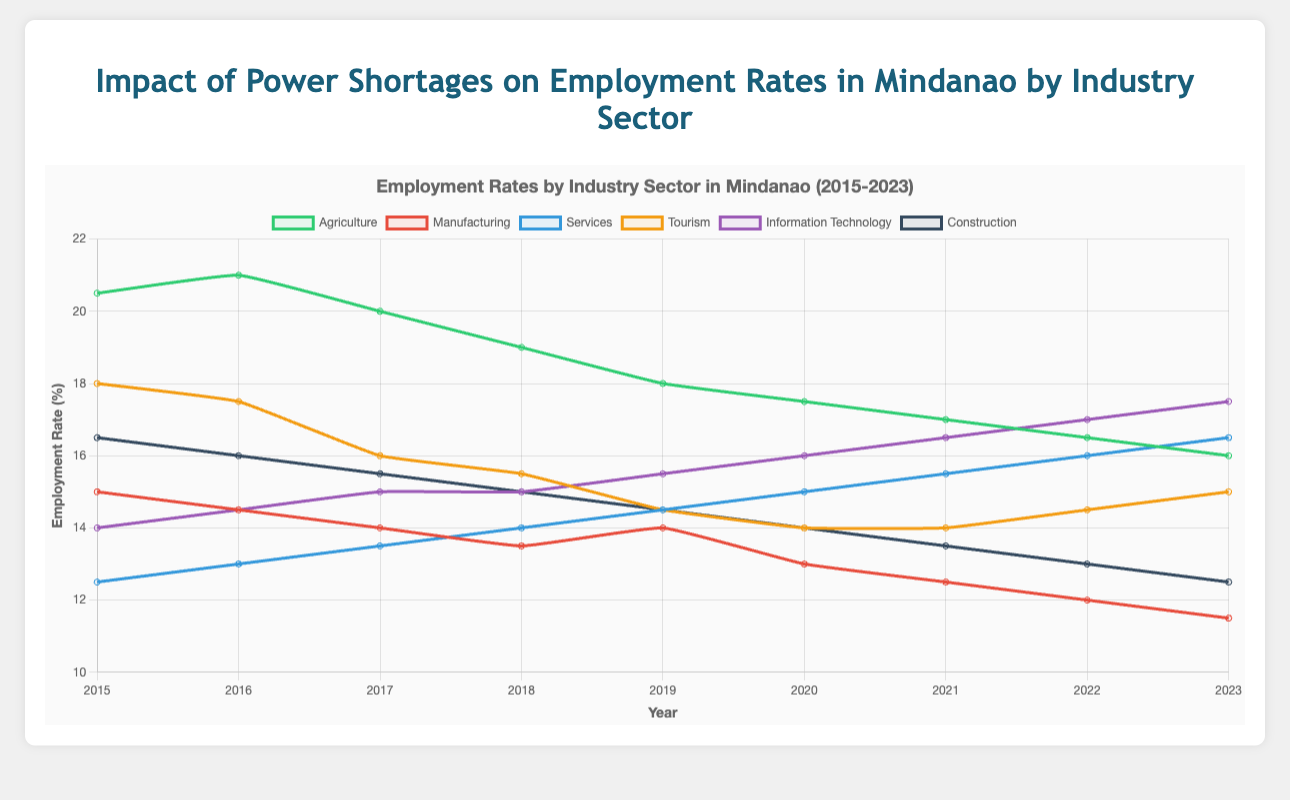What year had the highest employment rate in the Agriculture sector? By examining the graph, the peak in the Agriculture sector is visible in 2016 when the employment rate was at 21.0%
Answer: 2016 Between 2015 and 2023, which sector showed the most significant increase in employment rate? To determine which sector showed the most increase, we compare the employment rates in 2015 to those in 2023. The Information Technology sector increased from 14.0% in 2015 to 17.5% in 2023, showing the most significant rise.
Answer: Information Technology In which year did the Manufacturing sector see the lowest employment rate? By reviewing the plot for the Manufacturing sector, it is evident that the lowest point is in 2023 with an employment rate of 11.5%
Answer: 2023 What is the difference in employment rates between the Agriculture and Services sectors in 2023? Reviewing the plot, in 2023, Agriculture is at 16.0% and Services are at 16.5%. The difference is calculated as 16.5% - 16.0% = 0.5%
Answer: 0.5% By how much did the employment rate in the Tourism sector decrease from 2015 to 2019? In 2015, Tourism had an employment rate of 18.0%, and in 2019, it was 14.5%. The decrease is calculated as 18.0% - 14.5% = 3.5%
Answer: 3.5% Which sector had the highest employment rate in 2018? Analyzing the plot for the year 2018, the Agriculture sector showed the highest rate at 19.0%
Answer: Agriculture Between 2019 and 2022, which sector showed the most minimal fluctuation in terms of employment rates? By examining the lines for each sector between these years, Construction showed minimal fluctuation, with rates ranging narrowly between 14.5% and 13.0%
Answer: Construction What sector consistently increased its employment rate every year from 2015 to 2023? By tracing the trends, the Information Technology sector is the only one that consistently rose from 14.0% in 2015 to 17.5% in 2023
Answer: Information Technology How did the employment rate in Services change from 2015 to 2023? The Services sector started at 12.5% in 2015 and increased to 16.5% in 2023. The change is 16.5% - 12.5% = 4.0%
Answer: Increased by 4.0% Which two sectors had equal employment rates in 2021? Observing the plot for 2021, both Tourism and Information Technology sectors had an employment rate of 14.0%
Answer: Tourism and Information Technology 